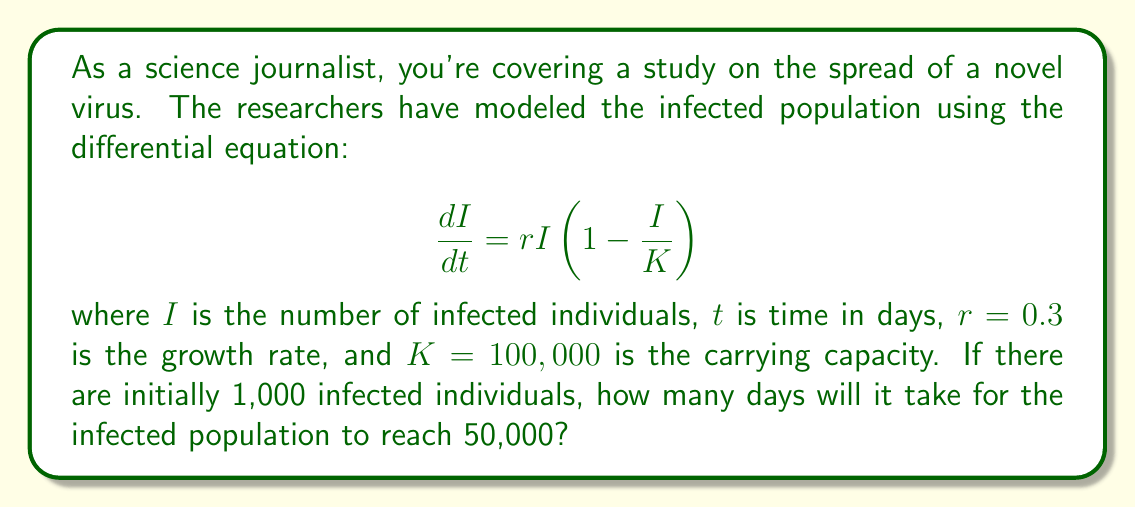Teach me how to tackle this problem. To solve this problem, we'll follow these steps:

1) The given differential equation is a logistic growth model. The solution to this equation is:

   $$I(t) = \frac{K}{1 + (\frac{K}{I_0} - 1)e^{-rt}}$$

   where $I_0$ is the initial number of infected individuals.

2) We're given:
   $K = 100,000$
   $r = 0.3$
   $I_0 = 1,000$
   We need to find $t$ when $I(t) = 50,000$

3) Let's substitute these values into the equation:

   $$50,000 = \frac{100,000}{1 + (\frac{100,000}{1,000} - 1)e^{-0.3t}}$$

4) Simplify:

   $$50,000 = \frac{100,000}{1 + 99e^{-0.3t}}$$

5) Multiply both sides by the denominator:

   $$50,000(1 + 99e^{-0.3t}) = 100,000$$

6) Distribute:

   $$50,000 + 4,950,000e^{-0.3t} = 100,000$$

7) Subtract 50,000 from both sides:

   $$4,950,000e^{-0.3t} = 50,000$$

8) Divide both sides by 4,950,000:

   $$e^{-0.3t} = \frac{1}{99}$$

9) Take the natural log of both sides:

   $$-0.3t = \ln(\frac{1}{99}) = -\ln(99)$$

10) Solve for $t$:

    $$t = \frac{\ln(99)}{0.3} \approx 15.4$$

Therefore, it will take approximately 15.4 days for the infected population to reach 50,000.
Answer: 15.4 days 